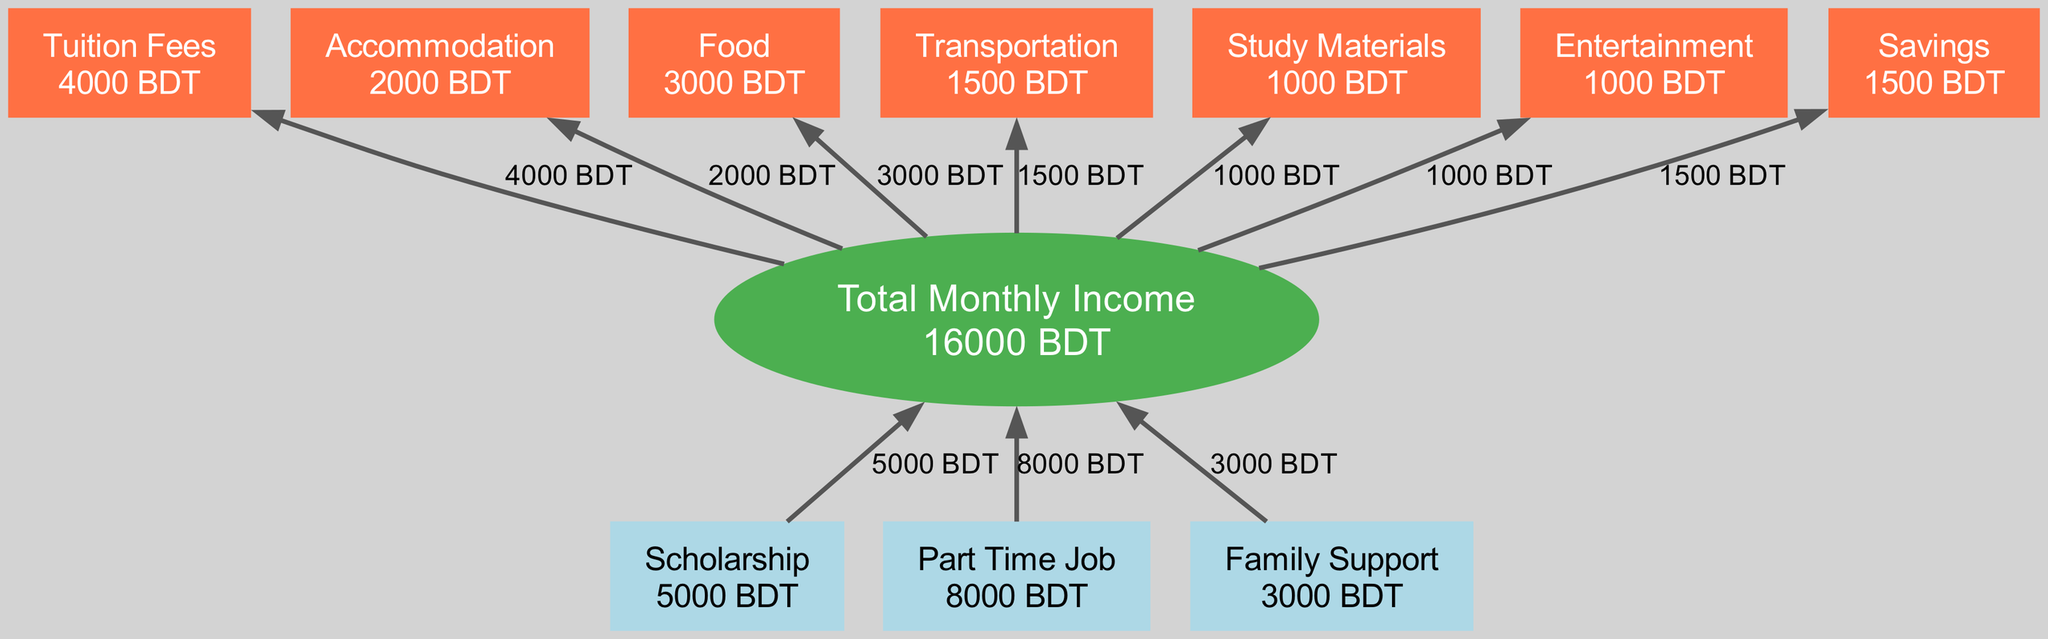What is the total monthly income? The total monthly income is calculated by summing up all the sources of income: scholarship (5000 BDT) + part-time job (8000 BDT) + family support (3000 BDT) = 5000 + 8000 + 3000 = 16000 BDT.
Answer: 16000 BDT Which expense category has the highest allocation? By examining the expenses, the highest allocation is for food, which is 3000 BDT when comparing all the individual expense amounts.
Answer: Food How many sources of income are there? The diagram lists three sources of income: scholarship, part-time job, and family support. Counting these sources gives a total of 3.
Answer: 3 What is the expense for transportation? The specific node for transportation shows an expense of 1500 BDT. This value can be directly found in the expenses section of the diagram.
Answer: 1500 BDT What percentage of the total income is allocated to savings? To calculate the percentage of total income that is allocated to savings, divide the savings amount (1500 BDT) by the total income (16000 BDT) and multiply by 100: (1500/16000) * 100 = 9.375%. This shows that savings represent 9.375% of the total monthly income.
Answer: 9.375% Which category has the lowest expense allocation? Looking at the expenses listed, study materials and entertainment each have an allocation of 1000 BDT, making them the categories with the lowest allocation. Since both are the same, one of them can be identified as having the lowest allocation.
Answer: Study materials What is the total amount at the bottom of the flow chart? The bottom of the flow chart summarizes all expense allocations and represents the total monthly expenditure. The total expenses sum up to 15000 BDT when adding up each category's allocation: 4000 + 2000 + 3000 + 1500 + 1000 + 1000 + 1500 = 15000 BDT.
Answer: 15000 BDT How does the total monthly income compare to total expenses? By comparing total monthly income (16000 BDT) with total expenses (15000 BDT), you can see that monthly income exceeds expenses. The difference is 16000 BDT - 15000 BDT = 1000 BDT, indicating that income surpasses outgoing expenses.
Answer: Income exceeds expenses 